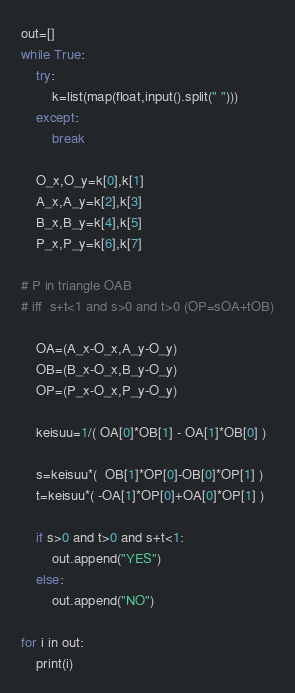Convert code to text. <code><loc_0><loc_0><loc_500><loc_500><_Python_>out=[]
while True:
	try:
		k=list(map(float,input().split(" ")))
	except:
		break

	O_x,O_y=k[0],k[1]
	A_x,A_y=k[2],k[3]
	B_x,B_y=k[4],k[5]
	P_x,P_y=k[6],k[7]

# P in triangle OAB
# iff  s+t<1 and s>0 and t>0 (OP=sOA+tOB)

	OA=(A_x-O_x,A_y-O_y)
	OB=(B_x-O_x,B_y-O_y)
	OP=(P_x-O_x,P_y-O_y)

	keisuu=1/( OA[0]*OB[1] - OA[1]*OB[0] )

	s=keisuu*(  OB[1]*OP[0]-OB[0]*OP[1] )
	t=keisuu*( -OA[1]*OP[0]+OA[0]*OP[1] )

	if s>0 and t>0 and s+t<1:
		out.append("YES")
	else:
		out.append("NO")

for i in out:
	print(i)</code> 